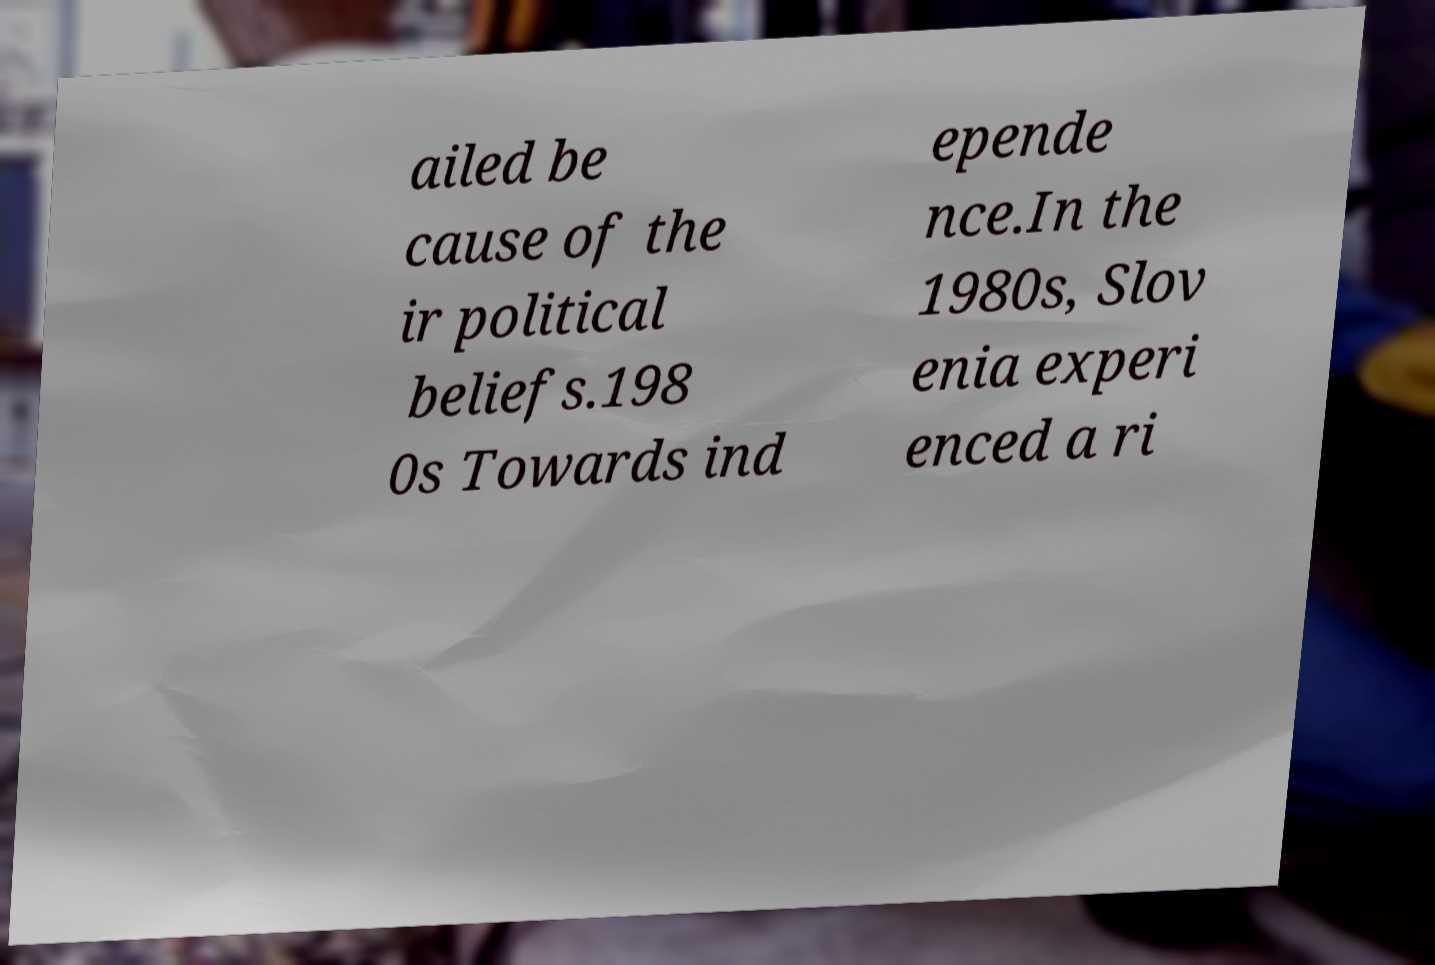Can you accurately transcribe the text from the provided image for me? ailed be cause of the ir political beliefs.198 0s Towards ind epende nce.In the 1980s, Slov enia experi enced a ri 